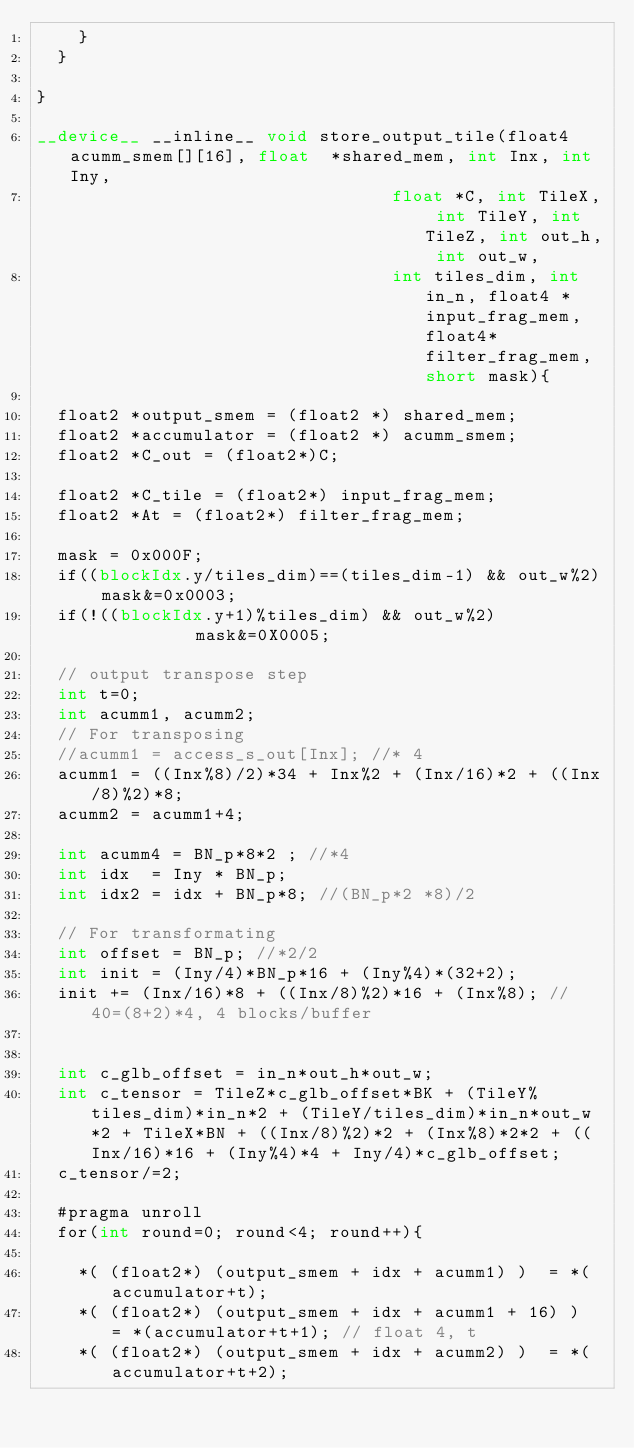<code> <loc_0><loc_0><loc_500><loc_500><_Cuda_>    }
  }

}

__device__ __inline__ void store_output_tile(float4 acumm_smem[][16], float  *shared_mem, int Inx, int Iny,
                                  float *C, int TileX, int TileY, int TileZ, int out_h, int out_w, 
                                  int tiles_dim, int in_n, float4 *input_frag_mem, float4* filter_frag_mem, short mask){
  
  float2 *output_smem = (float2 *) shared_mem;
  float2 *accumulator = (float2 *) acumm_smem;
  float2 *C_out = (float2*)C;

  float2 *C_tile = (float2*) input_frag_mem;
  float2 *At = (float2*) filter_frag_mem;

  mask = 0x000F;
  if((blockIdx.y/tiles_dim)==(tiles_dim-1) && out_w%2) mask&=0x0003;
  if(!((blockIdx.y+1)%tiles_dim) && out_w%2)           mask&=0X0005;
  
  // output transpose step
  int t=0;
  int acumm1, acumm2;
  // For transposing
  //acumm1 = access_s_out[Inx]; //* 4
  acumm1 = ((Inx%8)/2)*34 + Inx%2 + (Inx/16)*2 + ((Inx/8)%2)*8;
  acumm2 = acumm1+4;
                                    
  int acumm4 = BN_p*8*2 ; //*4
  int idx  = Iny * BN_p;
  int idx2 = idx + BN_p*8; //(BN_p*2 *8)/2

  // For transformating
  int offset = BN_p; //*2/2
  int init = (Iny/4)*BN_p*16 + (Iny%4)*(32+2);
  init += (Inx/16)*8 + ((Inx/8)%2)*16 + (Inx%8); //40=(8+2)*4, 4 blocks/buffer


  int c_glb_offset = in_n*out_h*out_w;                    
  int c_tensor = TileZ*c_glb_offset*BK + (TileY%tiles_dim)*in_n*2 + (TileY/tiles_dim)*in_n*out_w*2 + TileX*BN + ((Inx/8)%2)*2 + (Inx%8)*2*2 + ((Inx/16)*16 + (Iny%4)*4 + Iny/4)*c_glb_offset;
  c_tensor/=2; 

  #pragma unroll                                  
  for(int round=0; round<4; round++){

    *( (float2*) (output_smem + idx + acumm1) )  = *(accumulator+t);
    *( (float2*) (output_smem + idx + acumm1 + 16) )  = *(accumulator+t+1); // float 4, t
    *( (float2*) (output_smem + idx + acumm2) )  = *(accumulator+t+2);</code> 